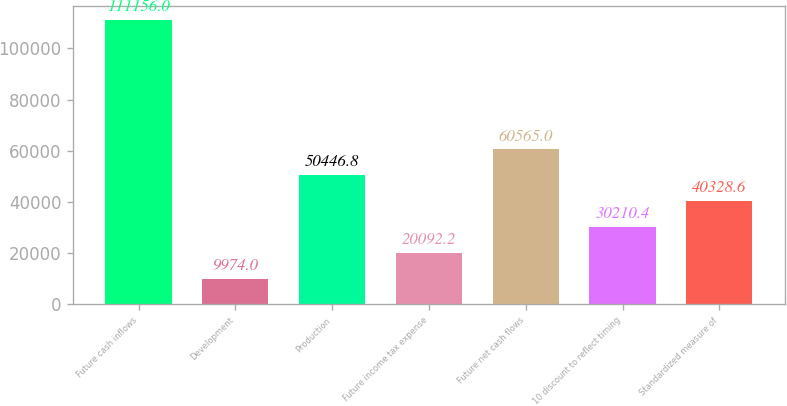Convert chart to OTSL. <chart><loc_0><loc_0><loc_500><loc_500><bar_chart><fcel>Future cash inflows<fcel>Development<fcel>Production<fcel>Future income tax expense<fcel>Future net cash flows<fcel>10 discount to reflect timing<fcel>Standardized measure of<nl><fcel>111156<fcel>9974<fcel>50446.8<fcel>20092.2<fcel>60565<fcel>30210.4<fcel>40328.6<nl></chart> 